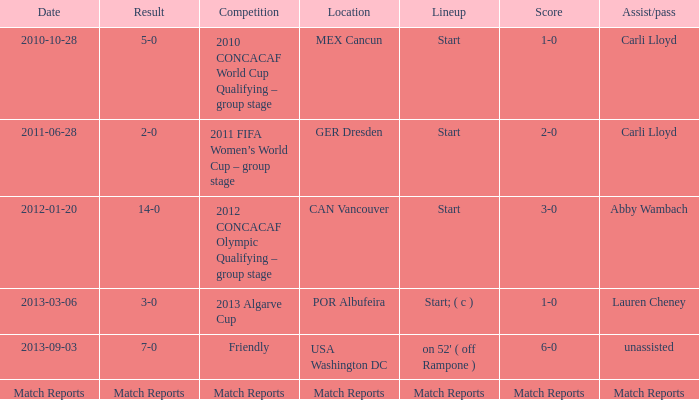Where has a score of match reports? Match Reports. 